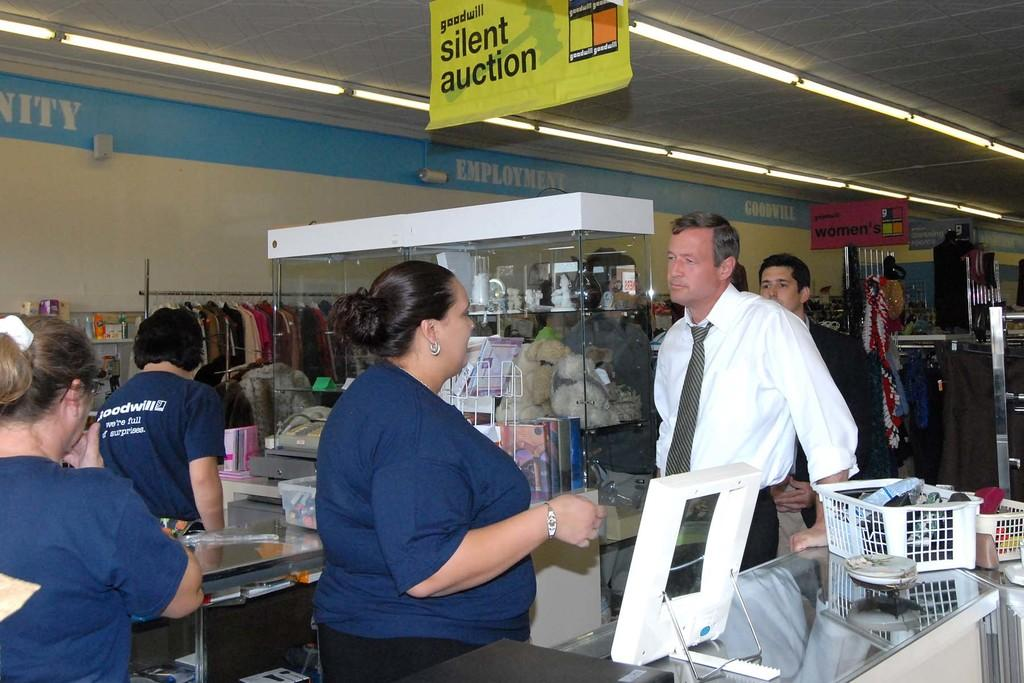What type of location is depicted in the image? The image is an inside view of a store. Are there any people present in the store? Yes, there are people in the store. What can be found in the store besides people? There are objects, tables, baskets, clothes, glass, banners, and lights in the store. What is the structure of the store made of? The store has a wall, which is a part of its structure. Can you see any snakes slithering on the floor in the store? No, there are no snakes visible in the image. What type of goldfish can be seen swimming in the baskets in the store? There are no goldfish present in the image; the baskets are used for holding clothes. 